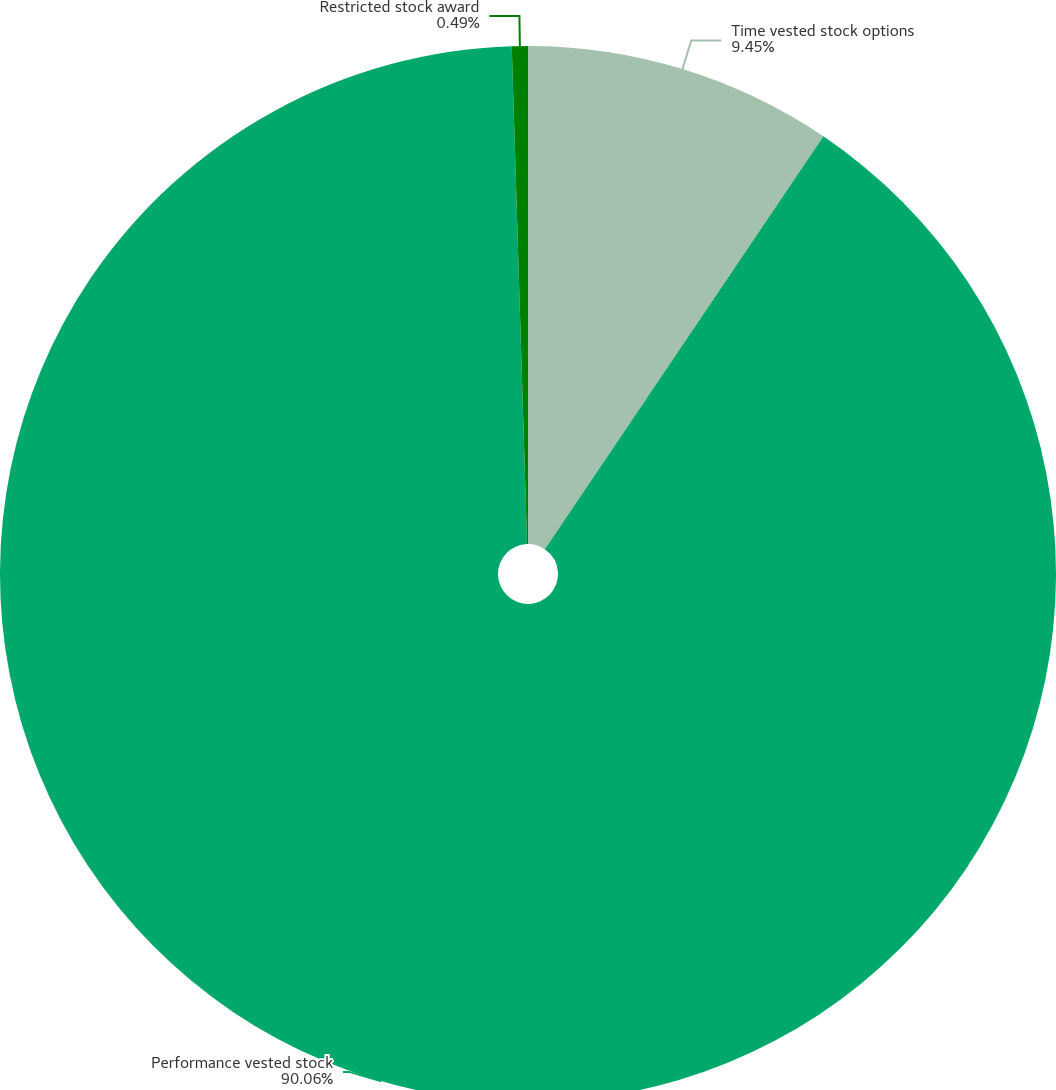Convert chart. <chart><loc_0><loc_0><loc_500><loc_500><pie_chart><fcel>Time vested stock options<fcel>Performance vested stock<fcel>Restricted stock award<nl><fcel>9.45%<fcel>90.06%<fcel>0.49%<nl></chart> 